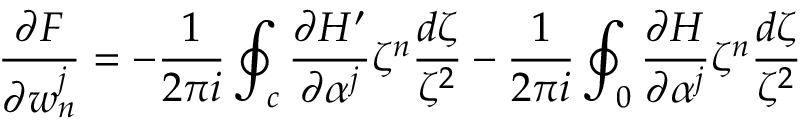Convert formula to latex. <formula><loc_0><loc_0><loc_500><loc_500>\frac { \partial F } { \partial w _ { n } ^ { j } } = - \frac { 1 } { 2 \pi i } \oint _ { c } \frac { \partial H ^ { \prime } } { \partial \alpha ^ { j } } \zeta ^ { n } \frac { d \zeta } { \zeta ^ { 2 } } - \frac { 1 } { 2 \pi i } \oint _ { 0 } \frac { \partial H } { \partial \alpha ^ { j } } \zeta ^ { n } \frac { d \zeta } { \zeta ^ { 2 } }</formula> 